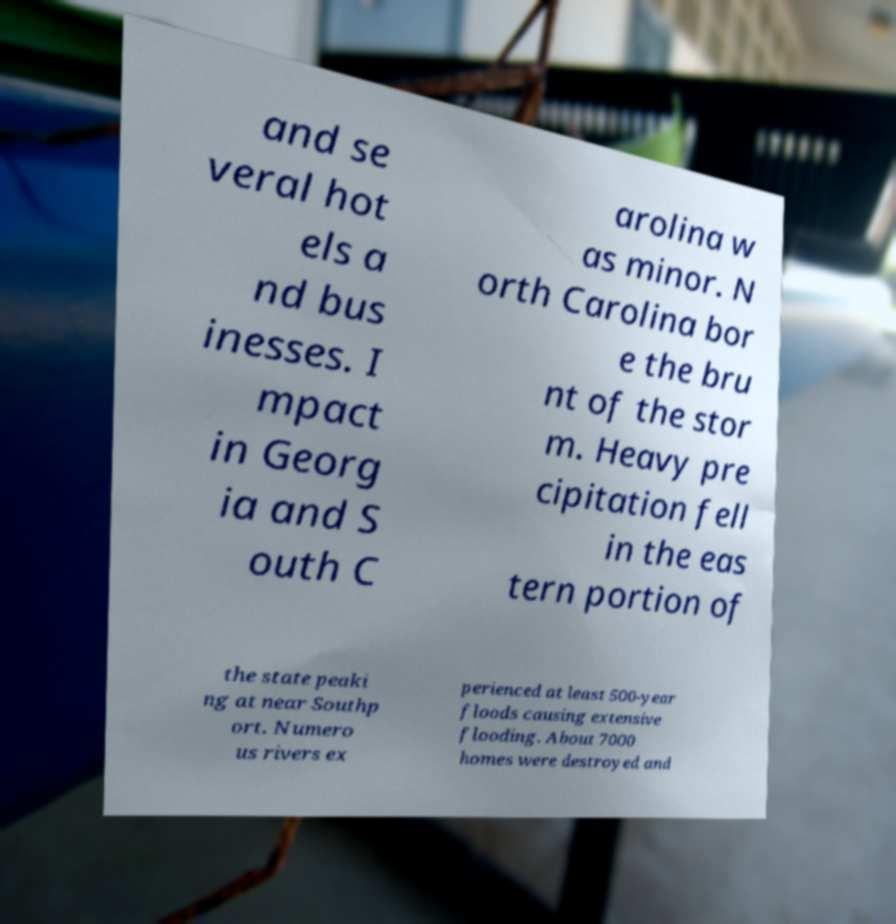Can you accurately transcribe the text from the provided image for me? and se veral hot els a nd bus inesses. I mpact in Georg ia and S outh C arolina w as minor. N orth Carolina bor e the bru nt of the stor m. Heavy pre cipitation fell in the eas tern portion of the state peaki ng at near Southp ort. Numero us rivers ex perienced at least 500-year floods causing extensive flooding. About 7000 homes were destroyed and 